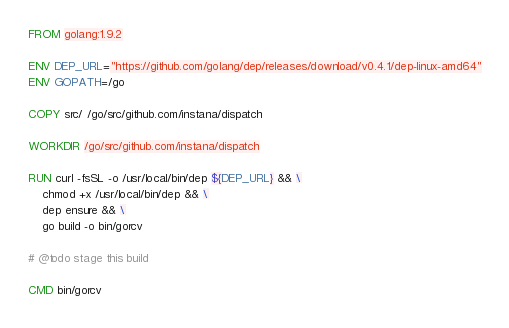Convert code to text. <code><loc_0><loc_0><loc_500><loc_500><_Dockerfile_>FROM golang:1.9.2

ENV DEP_URL="https://github.com/golang/dep/releases/download/v0.4.1/dep-linux-amd64"
ENV GOPATH=/go

COPY src/ /go/src/github.com/instana/dispatch

WORKDIR /go/src/github.com/instana/dispatch

RUN curl -fsSL -o /usr/local/bin/dep ${DEP_URL} && \
	chmod +x /usr/local/bin/dep && \
    dep ensure && \
    go build -o bin/gorcv

# @todo stage this build

CMD bin/gorcv
</code> 